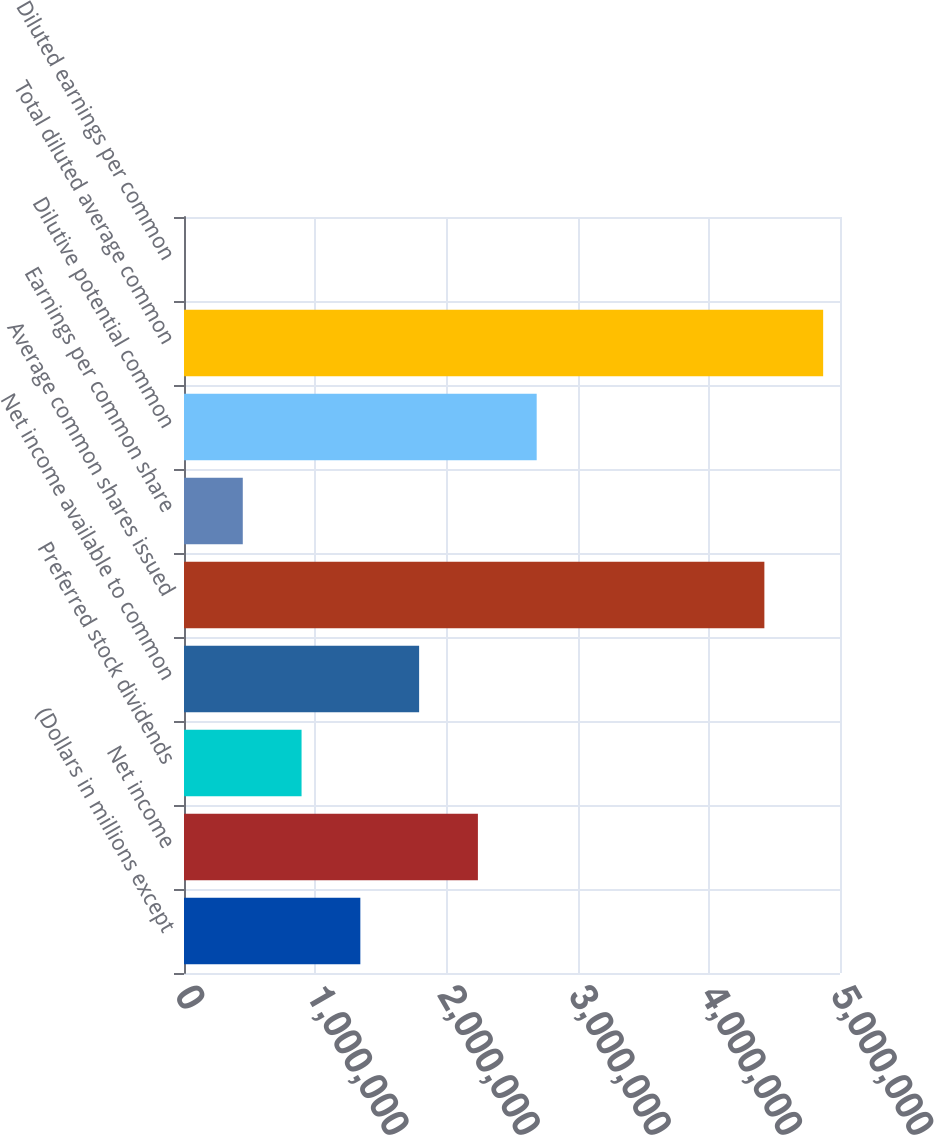<chart> <loc_0><loc_0><loc_500><loc_500><bar_chart><fcel>(Dollars in millions except<fcel>Net income<fcel>Preferred stock dividends<fcel>Net income available to common<fcel>Average common shares issued<fcel>Earnings per common share<fcel>Dilutive potential common<fcel>Total diluted average common<fcel>Diluted earnings per common<nl><fcel>1.34408e+06<fcel>2.24013e+06<fcel>896053<fcel>1.7921e+06<fcel>4.42358e+06<fcel>448028<fcel>2.68815e+06<fcel>4.8716e+06<fcel>3.3<nl></chart> 